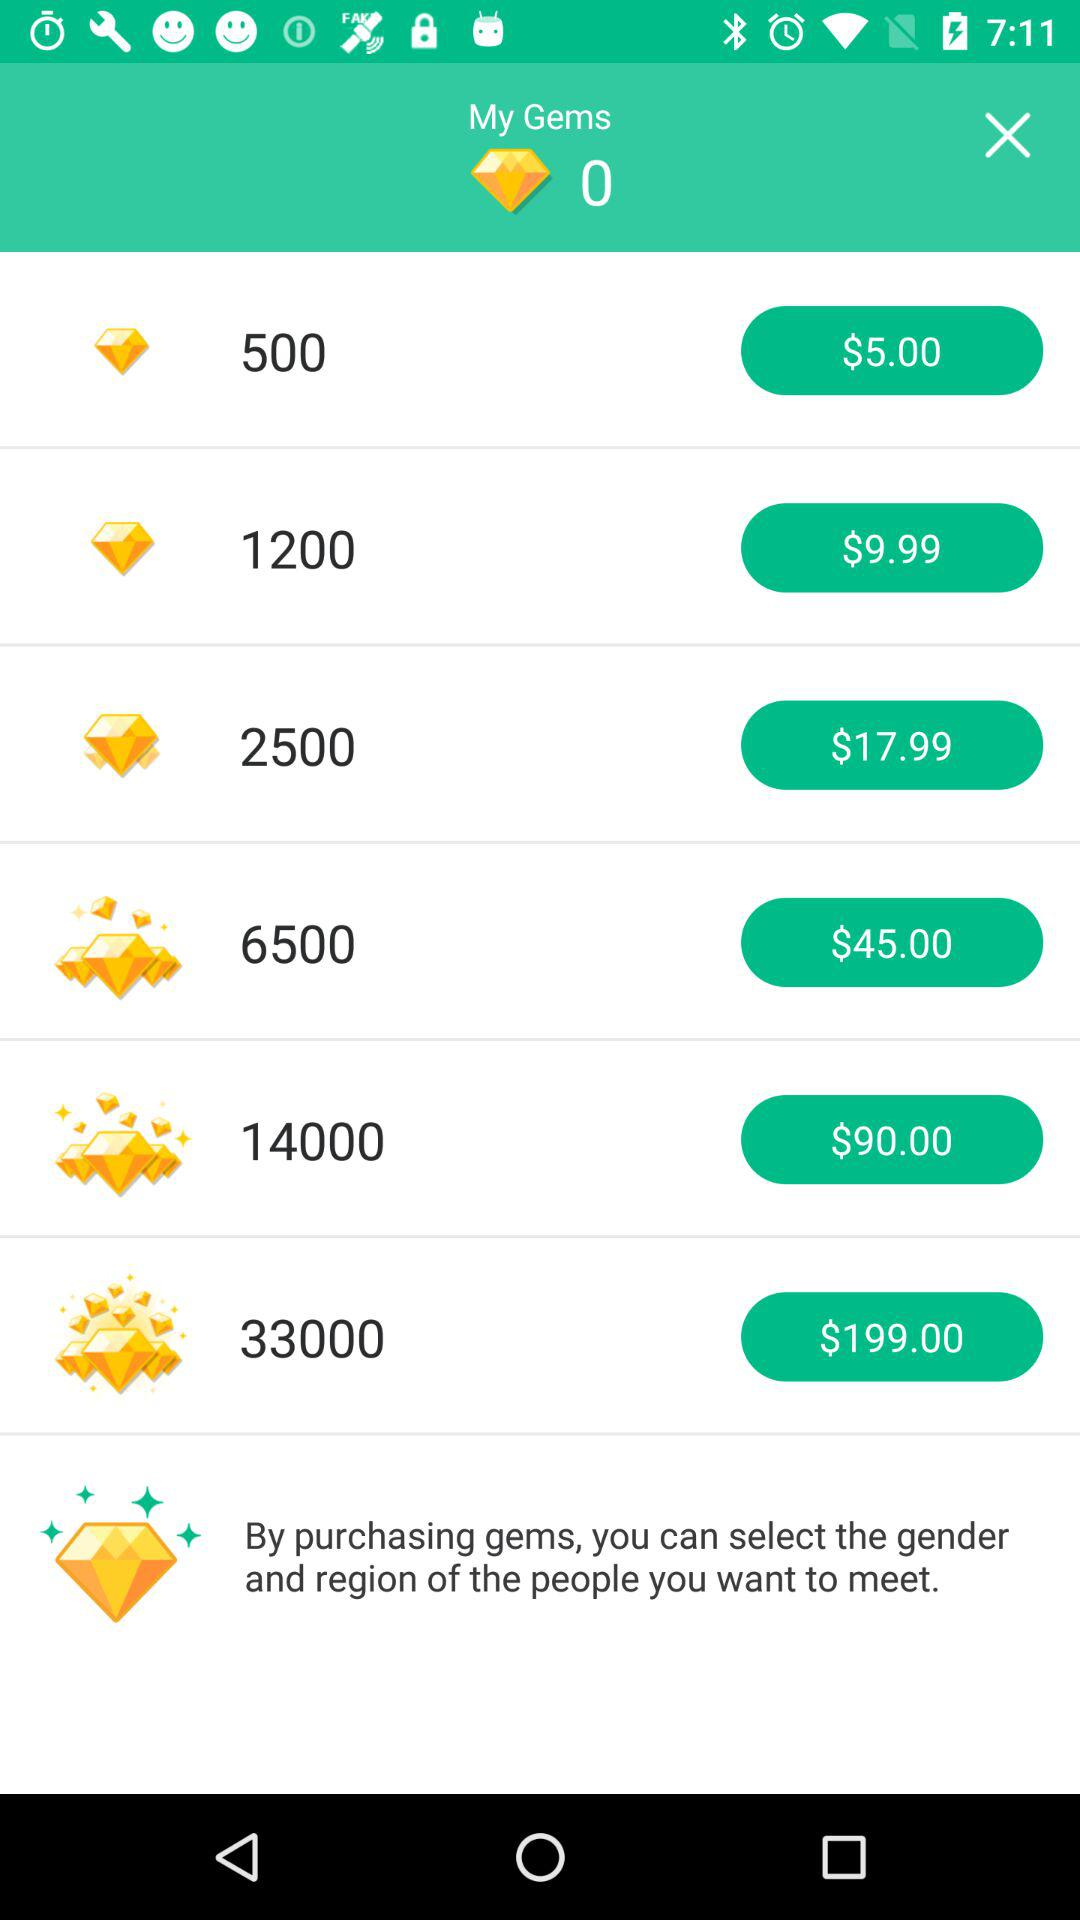How many gems are there for $5.00? There are 500 gems for $5.00. 